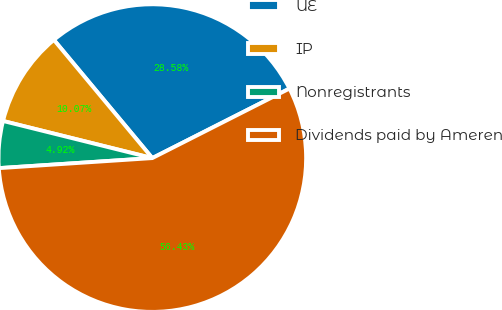Convert chart. <chart><loc_0><loc_0><loc_500><loc_500><pie_chart><fcel>UE<fcel>IP<fcel>Nonregistrants<fcel>Dividends paid by Ameren<nl><fcel>28.58%<fcel>10.07%<fcel>4.92%<fcel>56.42%<nl></chart> 